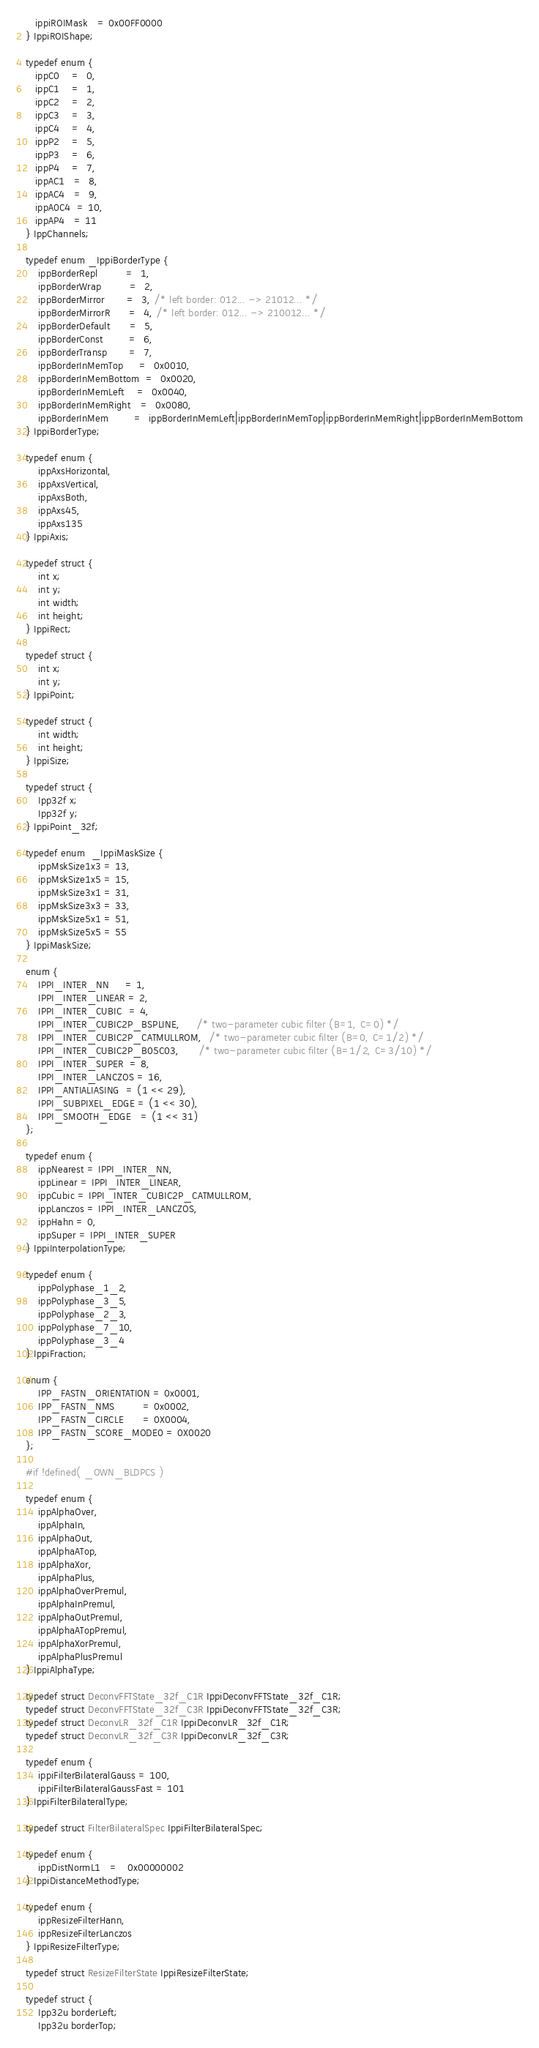Convert code to text. <code><loc_0><loc_0><loc_500><loc_500><_C_>   ippiROIMask   = 0x00FF0000
} IppiROIShape;

typedef enum {
   ippC0    =  0,
   ippC1    =  1,
   ippC2    =  2,
   ippC3    =  3,
   ippC4    =  4,
   ippP2    =  5,
   ippP3    =  6,
   ippP4    =  7,
   ippAC1   =  8,
   ippAC4   =  9,
   ippA0C4  = 10,
   ippAP4   = 11
} IppChannels;

typedef enum _IppiBorderType {
    ippBorderRepl         =  1,
    ippBorderWrap         =  2,
    ippBorderMirror       =  3, /* left border: 012... -> 21012... */
    ippBorderMirrorR      =  4, /* left border: 012... -> 210012... */
    ippBorderDefault      =  5,
    ippBorderConst        =  6,
    ippBorderTransp       =  7,
    ippBorderInMemTop     =  0x0010,
    ippBorderInMemBottom  =  0x0020,
    ippBorderInMemLeft    =  0x0040,
    ippBorderInMemRight   =  0x0080,
    ippBorderInMem        =  ippBorderInMemLeft|ippBorderInMemTop|ippBorderInMemRight|ippBorderInMemBottom
} IppiBorderType;

typedef enum {
    ippAxsHorizontal,
    ippAxsVertical,
    ippAxsBoth,
    ippAxs45,
    ippAxs135
} IppiAxis;

typedef struct {
    int x;
    int y;
    int width;
    int height;
} IppiRect;

typedef struct {
    int x;
    int y;
} IppiPoint;

typedef struct {
    int width;
    int height;
} IppiSize;

typedef struct {
    Ipp32f x;
    Ipp32f y;
} IppiPoint_32f;

typedef enum  _IppiMaskSize {
    ippMskSize1x3 = 13,
    ippMskSize1x5 = 15,
    ippMskSize3x1 = 31,
    ippMskSize3x3 = 33,
    ippMskSize5x1 = 51,
    ippMskSize5x5 = 55
} IppiMaskSize;

enum {
    IPPI_INTER_NN     = 1,
    IPPI_INTER_LINEAR = 2,
    IPPI_INTER_CUBIC  = 4,
    IPPI_INTER_CUBIC2P_BSPLINE,     /* two-parameter cubic filter (B=1, C=0) */
    IPPI_INTER_CUBIC2P_CATMULLROM,  /* two-parameter cubic filter (B=0, C=1/2) */
    IPPI_INTER_CUBIC2P_B05C03,      /* two-parameter cubic filter (B=1/2, C=3/10) */
    IPPI_INTER_SUPER  = 8,
    IPPI_INTER_LANCZOS = 16,
    IPPI_ANTIALIASING  = (1 << 29),
    IPPI_SUBPIXEL_EDGE = (1 << 30),
    IPPI_SMOOTH_EDGE   = (1 << 31)
};

typedef enum {
    ippNearest = IPPI_INTER_NN,
    ippLinear = IPPI_INTER_LINEAR,
    ippCubic = IPPI_INTER_CUBIC2P_CATMULLROM,
    ippLanczos = IPPI_INTER_LANCZOS,
    ippHahn = 0,
    ippSuper = IPPI_INTER_SUPER
} IppiInterpolationType;

typedef enum {
    ippPolyphase_1_2,
    ippPolyphase_3_5,
    ippPolyphase_2_3,
    ippPolyphase_7_10,
    ippPolyphase_3_4
} IppiFraction;

enum {
    IPP_FASTN_ORIENTATION = 0x0001,
    IPP_FASTN_NMS         = 0x0002,
    IPP_FASTN_CIRCLE      = 0X0004,
    IPP_FASTN_SCORE_MODE0 = 0X0020
};

#if !defined( _OWN_BLDPCS )

typedef enum {
    ippAlphaOver,
    ippAlphaIn,
    ippAlphaOut,
    ippAlphaATop,
    ippAlphaXor,
    ippAlphaPlus,
    ippAlphaOverPremul,
    ippAlphaInPremul,
    ippAlphaOutPremul,
    ippAlphaATopPremul,
    ippAlphaXorPremul,
    ippAlphaPlusPremul
} IppiAlphaType;

typedef struct DeconvFFTState_32f_C1R IppiDeconvFFTState_32f_C1R;
typedef struct DeconvFFTState_32f_C3R IppiDeconvFFTState_32f_C3R;
typedef struct DeconvLR_32f_C1R IppiDeconvLR_32f_C1R;
typedef struct DeconvLR_32f_C3R IppiDeconvLR_32f_C3R;

typedef enum {
    ippiFilterBilateralGauss = 100,
    ippiFilterBilateralGaussFast = 101
} IppiFilterBilateralType;

typedef struct FilterBilateralSpec IppiFilterBilateralSpec;

typedef enum {
    ippDistNormL1   =   0x00000002
} IppiDistanceMethodType;

typedef enum {
    ippResizeFilterHann,
    ippResizeFilterLanczos
} IppiResizeFilterType;

typedef struct ResizeFilterState IppiResizeFilterState;

typedef struct {
    Ipp32u borderLeft;
    Ipp32u borderTop;</code> 